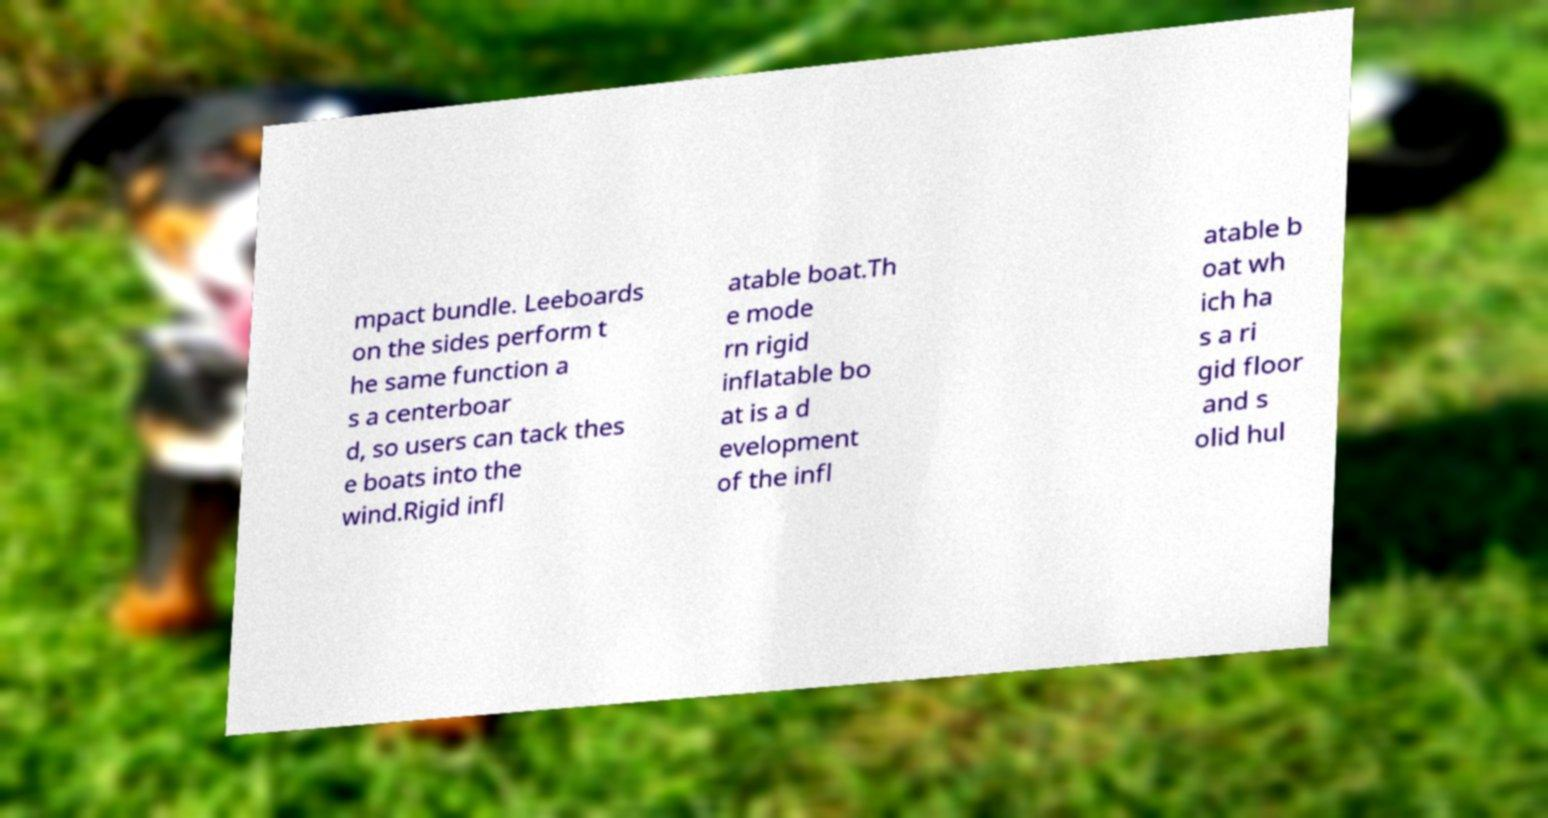For documentation purposes, I need the text within this image transcribed. Could you provide that? mpact bundle. Leeboards on the sides perform t he same function a s a centerboar d, so users can tack thes e boats into the wind.Rigid infl atable boat.Th e mode rn rigid inflatable bo at is a d evelopment of the infl atable b oat wh ich ha s a ri gid floor and s olid hul 